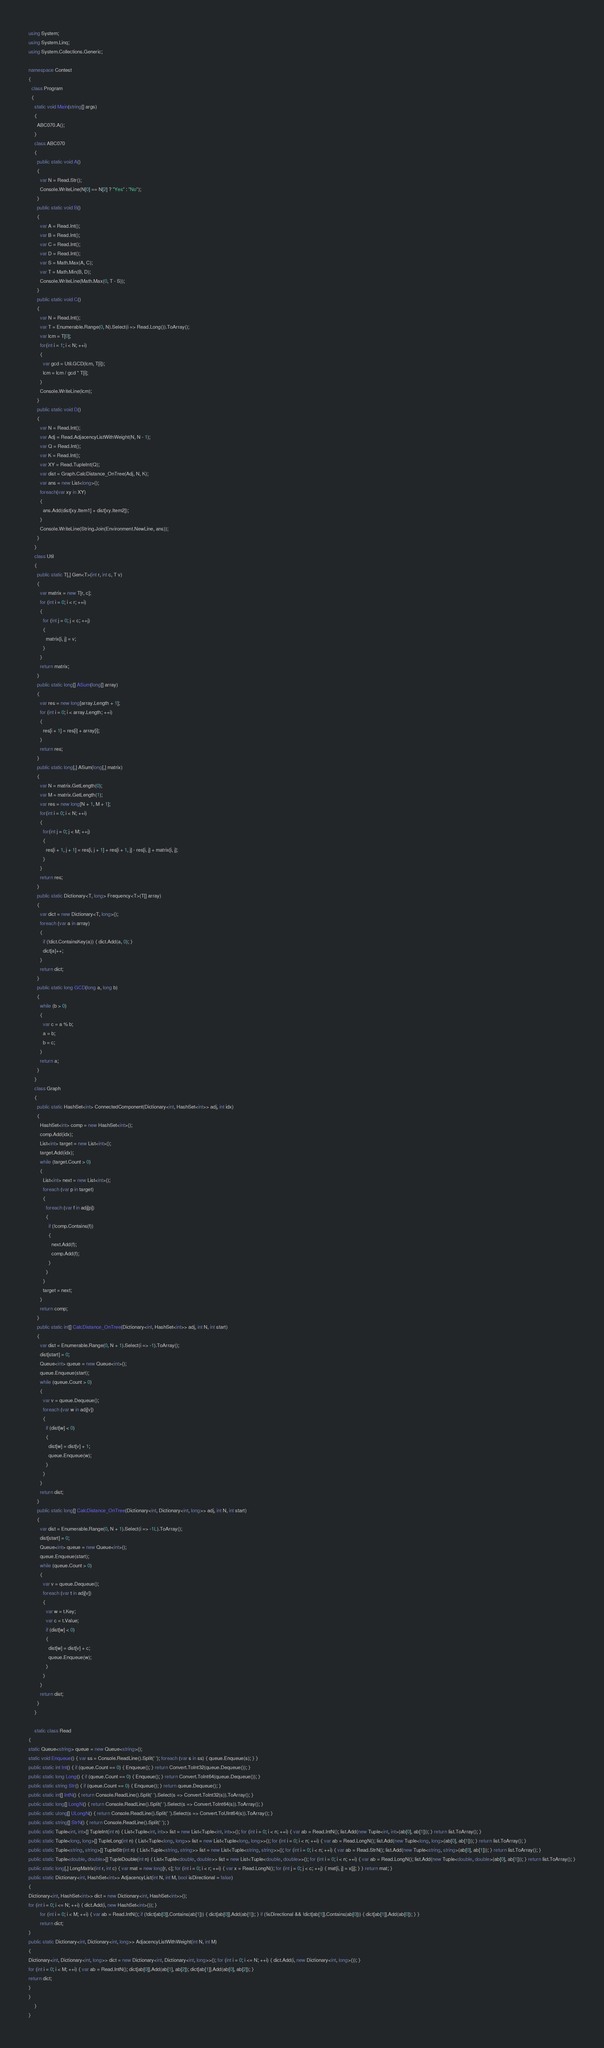Convert code to text. <code><loc_0><loc_0><loc_500><loc_500><_C#_>using System;
using System.Linq;
using System.Collections.Generic;

namespace Contest
{
  class Program
  {
    static void Main(string[] args)
    {
      ABC070.A();
    }
    class ABC070
    {
      public static void A()
      {
        var N = Read.Str();
        Console.WriteLine(N[0] == N[2] ? "Yes" : "No");
      }
      public static void B()
      {
        var A = Read.Int();
        var B = Read.Int();
        var C = Read.Int();
        var D = Read.Int();
        var S = Math.Max(A, C);
        var T = Math.Min(B, D);
        Console.WriteLine(Math.Max(0, T - S));
      }
      public static void C()
      {
        var N = Read.Int();
        var T = Enumerable.Range(0, N).Select(i => Read.Long()).ToArray();
        var lcm = T[0];
        for(int i = 1; i < N; ++i)
        {
          var gcd = Util.GCD(lcm, T[i]);
          lcm = lcm / gcd * T[i];
        }
        Console.WriteLine(lcm);
      }
      public static void D()
      {
        var N = Read.Int();
        var Adj = Read.AdjacencyListWithWeight(N, N - 1);
        var Q = Read.Int();
        var K = Read.Int();
        var XY = Read.TupleInt(Q);
        var dist = Graph.CalcDistance_OnTree(Adj, N, K);
        var ans = new List<long>();
        foreach(var xy in XY)
        {
          ans.Add(dist[xy.Item1] + dist[xy.Item2]);
        }
        Console.WriteLine(String.Join(Environment.NewLine, ans));
      }
    }
    class Util
    {
      public static T[,] Gen<T>(int r, int c, T v)
      {
        var matrix = new T[r, c];
        for (int i = 0; i < r; ++i)
        {
          for (int j = 0; j < c; ++j)
          {
            matrix[i, j] = v;
          }
        }
        return matrix;
      }
      public static long[] ASum(long[] array)
      {
        var res = new long[array.Length + 1];
        for (int i = 0; i < array.Length; ++i)
        {
          res[i + 1] = res[i] + array[i];
        }
        return res;
      }
      public static long[,] ASum(long[,] matrix)
      {
        var N = matrix.GetLength(0);
        var M = matrix.GetLength(1);
        var res = new long[N + 1, M + 1];
        for(int i = 0; i < N; ++i)
        {
          for(int j = 0; j < M; ++j)
          {
            res[i + 1, j + 1] = res[i, j + 1] + res[i + 1, j] - res[i, j] + matrix[i, j];
          }
        }
        return res;
      }
      public static Dictionary<T, long> Frequency<T>(T[] array)
      {
        var dict = new Dictionary<T, long>();
        foreach (var a in array)
        {
          if (!dict.ContainsKey(a)) { dict.Add(a, 0); }
          dict[a]++;
        }
        return dict;
      }
      public static long GCD(long a, long b)
      {
        while (b > 0)
        {
          var c = a % b;
          a = b;
          b = c;
        }
        return a;
      }
    }
    class Graph
    {
      public static HashSet<int> ConnectedComponent(Dictionary<int, HashSet<int>> adj, int idx)
      {
        HashSet<int> comp = new HashSet<int>();
        comp.Add(idx);
        List<int> target = new List<int>();
        target.Add(idx);
        while (target.Count > 0)
        {
          List<int> next = new List<int>();
          foreach (var p in target)
          {
            foreach (var f in adj[p])
            {
              if (!comp.Contains(f))
              {
                next.Add(f);
                comp.Add(f);
              }
            }
          }
          target = next;
        }
        return comp;
      }
      public static int[] CalcDistance_OnTree(Dictionary<int, HashSet<int>> adj, int N, int start)
      {
        var dist = Enumerable.Range(0, N + 1).Select(i => -1).ToArray();
        dist[start] = 0;
        Queue<int> queue = new Queue<int>();
        queue.Enqueue(start);
        while (queue.Count > 0)
        {
          var v = queue.Dequeue();
          foreach (var w in adj[v])
          {
            if (dist[w] < 0)
            {
              dist[w] = dist[v] + 1;
              queue.Enqueue(w);
            }
          }
        }
        return dist;
      }
      public static long[] CalcDistance_OnTree(Dictionary<int, Dictionary<int, long>> adj, int N, int start)
      {
        var dist = Enumerable.Range(0, N + 1).Select(i => -1L).ToArray();
        dist[start] = 0;
        Queue<int> queue = new Queue<int>();
        queue.Enqueue(start);
        while (queue.Count > 0)
        {
          var v = queue.Dequeue();
          foreach (var t in adj[v])
          {
            var w = t.Key;
            var c = t.Value;
            if (dist[w] < 0)
            {
              dist[w] = dist[v] + c;
              queue.Enqueue(w);
            }
          }
        }
        return dist;
      }
    }

    static class Read
{
static Queue<string> queue = new Queue<string>();
static void Enqueue() { var ss = Console.ReadLine().Split(' '); foreach (var s in ss) { queue.Enqueue(s); } }
public static int Int() { if (queue.Count == 0) { Enqueue(); } return Convert.ToInt32(queue.Dequeue()); }
public static long Long() { if (queue.Count == 0) { Enqueue(); } return Convert.ToInt64(queue.Dequeue()); }
public static string Str() { if (queue.Count == 0) { Enqueue(); } return queue.Dequeue(); }
public static int[] IntN() { return Console.ReadLine().Split(' ').Select(s => Convert.ToInt32(s)).ToArray(); }
public static long[] LongN() { return Console.ReadLine().Split(' ').Select(s => Convert.ToInt64(s)).ToArray(); }
public static ulong[] ULongN() { return Console.ReadLine().Split(' ').Select(s => Convert.ToUInt64(s)).ToArray(); }
public static string[] StrN() { return Console.ReadLine().Split(' '); }
public static Tuple<int, int>[] TupleInt(int n) { List<Tuple<int, int>> list = new List<Tuple<int, int>>(); for (int i = 0; i < n; ++i) { var ab = Read.IntN(); list.Add(new Tuple<int, int>(ab[0], ab[1])); } return list.ToArray(); }
public static Tuple<long, long>[] TupleLong(int n) { List<Tuple<long, long>> list = new List<Tuple<long, long>>(); for (int i = 0; i < n; ++i) { var ab = Read.LongN(); list.Add(new Tuple<long, long>(ab[0], ab[1])); } return list.ToArray(); }
public static Tuple<string, string>[] TupleStr(int n) { List<Tuple<string, string>> list = new List<Tuple<string, string>>(); for (int i = 0; i < n; ++i) { var ab = Read.StrN(); list.Add(new Tuple<string, string>(ab[0], ab[1])); } return list.ToArray(); }
public static Tuple<double, double>[] TupleDouble(int n) { List<Tuple<double, double>> list = new List<Tuple<double, double>>(); for (int i = 0; i < n; ++i) { var ab = Read.LongN(); list.Add(new Tuple<double, double>(ab[0], ab[1])); } return list.ToArray(); }
public static long[,] LongMatrix(int r, int c) { var mat = new long[r, c]; for (int i = 0; i < r; ++i) { var x = Read.LongN(); for (int j = 0; j < c; ++j) { mat[i, j] = x[j]; } } return mat; }
public static Dictionary<int, HashSet<int>> AdjacencyList(int N, int M, bool isDirectional = false)
{
Dictionary<int, HashSet<int>> dict = new Dictionary<int, HashSet<int>>();
for (int i = 0; i <= N; ++i) { dict.Add(i, new HashSet<int>()); }
        for (int i = 0; i < M; ++i) { var ab = Read.IntN(); if (!dict[ab[0]].Contains(ab[1])) { dict[ab[0]].Add(ab[1]); } if (!isDirectional && !dict[ab[1]].Contains(ab[0])) { dict[ab[1]].Add(ab[0]); } }
        return dict;
}
public static Dictionary<int, Dictionary<int, long>> AdjacencyListWithWeight(int N, int M)
{
Dictionary<int, Dictionary<int, long>> dict = new Dictionary<int, Dictionary<int, long>>(); for (int i = 0; i <= N; ++i) { dict.Add(i, new Dictionary<int, long>()); }
for (int i = 0; i < M; ++i) { var ab = Read.IntN(); dict[ab[0]].Add(ab[1], ab[2]); dict[ab[1]].Add(ab[0], ab[2]); }
return dict;
}
}
    }
}
</code> 